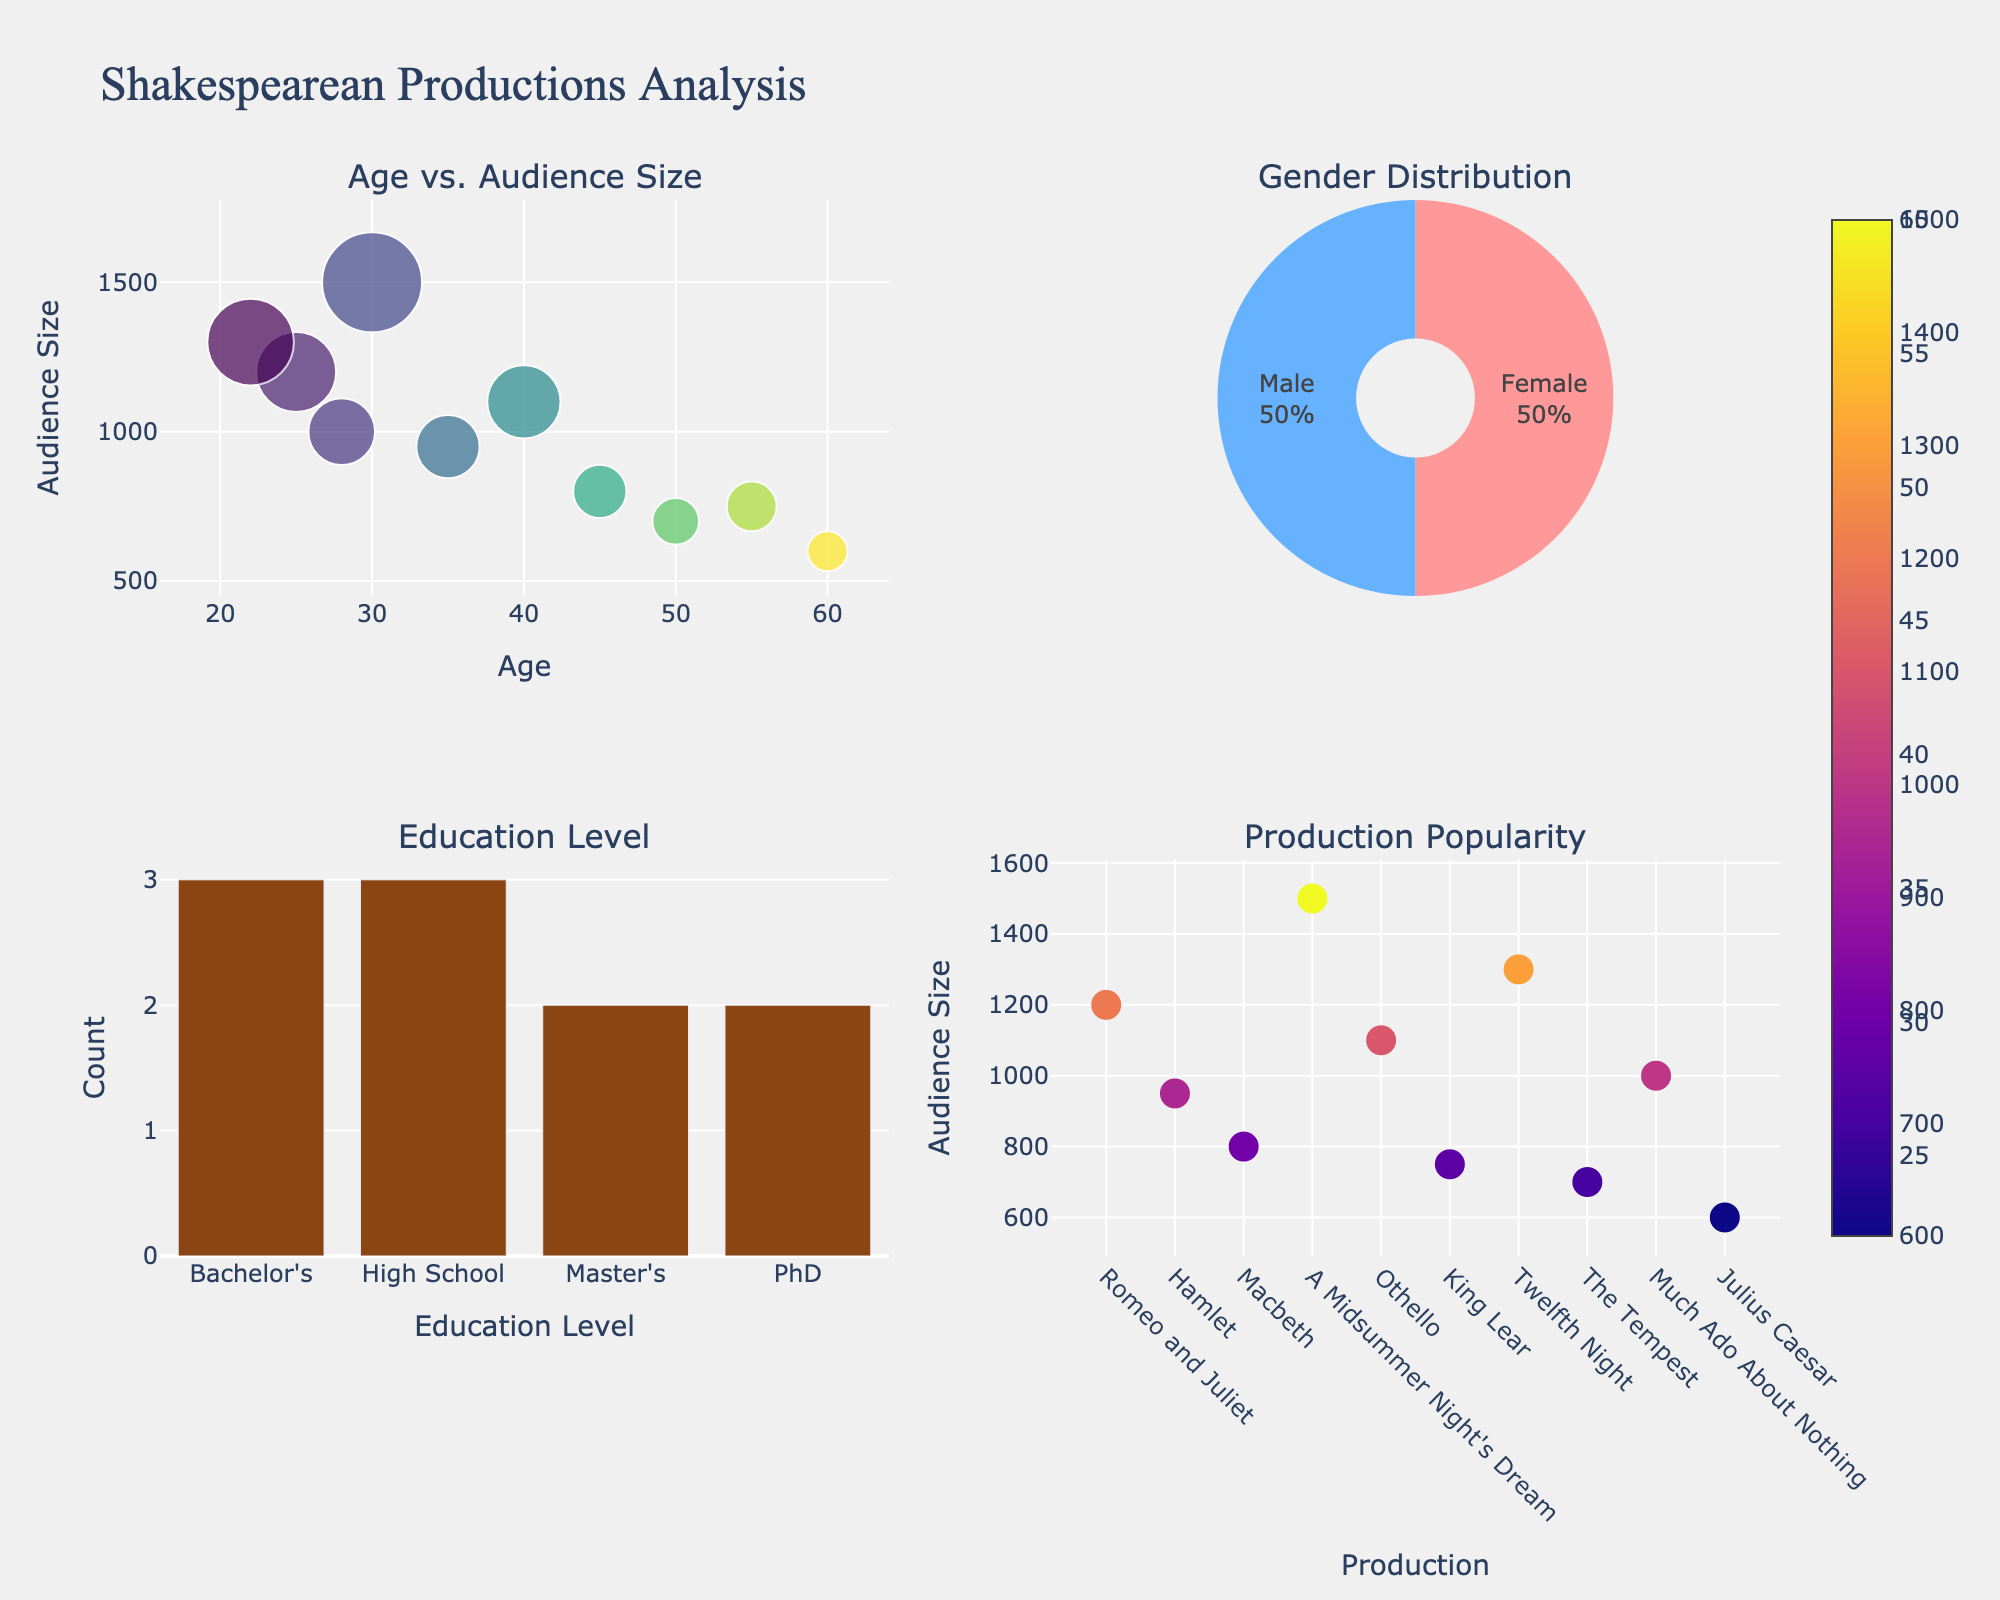What's the most popular Shakespearean production based on audience size? Look at the subplot titled "Production Popularity". The production with the highest audience size will have the largest bubble. The largest bubble corresponds to "A Midsummer Night's Dream".
Answer: A Midsummer Night's Dream What is the average age of the audience? Calculate the sum of all ages: 25 + 35 + 45 + 30 + 40 + 55 + 22 + 50 + 28 + 60 = 390. Then divide by the number of data points, which is 10: 390 / 10 = 39.
Answer: 39 What is the gender distribution of the audience? Look at the subplot titled "Gender Distribution". The pie chart shows two segments: one for females (pink) and one for males (blue). The percentages can be read directly off the pie chart.
Answer: About 50% Female, 50% Male Which production has the smallest audience? Look at the subplot titled "Production Popularity". The smallest bubble corresponds to "Julius Caesar" with an audience size of 600.
Answer: Julius Caesar How many audience members have a PhD? Look at the subplot titled "Education Level". The bar chart gives the count for each education level. Identify the bar labeled "PhD" and observe its height. There are 2 PhD-level audience members.
Answer: 2 What age group shows a higher preference for "Twelfth Night"? Look at the subplot titled "Age vs. Audience Size". The bubble corresponding to "Twelfth Night" is at an age of 22. Therefore, younger audiences show a higher preference for "Twelfth Night".
Answer: Younger Compare the audience size of "Hamlet" and "Macbeth". Which one is more popular? Look at the subplot titled "Production Popularity". Compare the bubble sizes for "Hamlet" and "Macbeth". "Hamlet" has an audience size of 950, whereas "Macbeth" has an audience size of 800. Therefore, "Hamlet" is more popular.
Answer: Hamlet Which education level has the highest representation in the audience? Look at the subplot titled "Education Level". The tallest bar represents the highest count. This bar is labeled "Bachelor's".
Answer: Bachelor's What is the most common age group attending the productions? Look at the subplot titled "Age vs. Audience Size". Notice the concentration of bubbles along the x-axis (Age). Most bubbles are around the age group of 20-40.
Answer: 20-40 What is the relationship between age and audience size for the productions? Look at the subplot titled "Age vs. Audience Size". The scatter plot shows no clear linear relationship; however, larger audiences are seen among younger to middle-aged groups rather than older ages.
Answer: No clear linear relationship; larger audiences in younger to middle-aged groups 